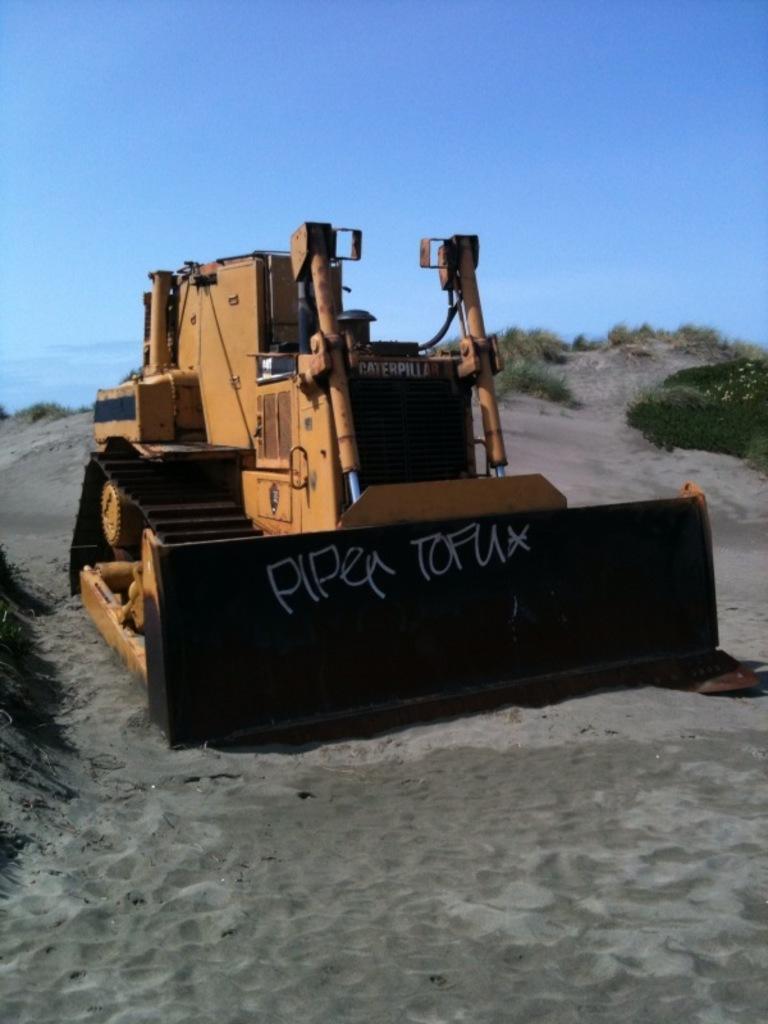Please provide a concise description of this image. In this image there is a bulldozer in the middle. At the bottom there is sand. At the top there is the sky. On the right side top there are few plants in the soil 